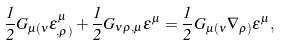Convert formula to latex. <formula><loc_0><loc_0><loc_500><loc_500>\frac { 1 } { 2 } G _ { \mu ( \nu } \epsilon ^ { \mu } _ { , \rho ) } + \frac { 1 } { 2 } G _ { \nu \rho , \mu } \epsilon ^ { \mu } = \frac { 1 } { 2 } G _ { \mu ( \nu } \nabla _ { \rho ) } \epsilon ^ { \mu } ,</formula> 